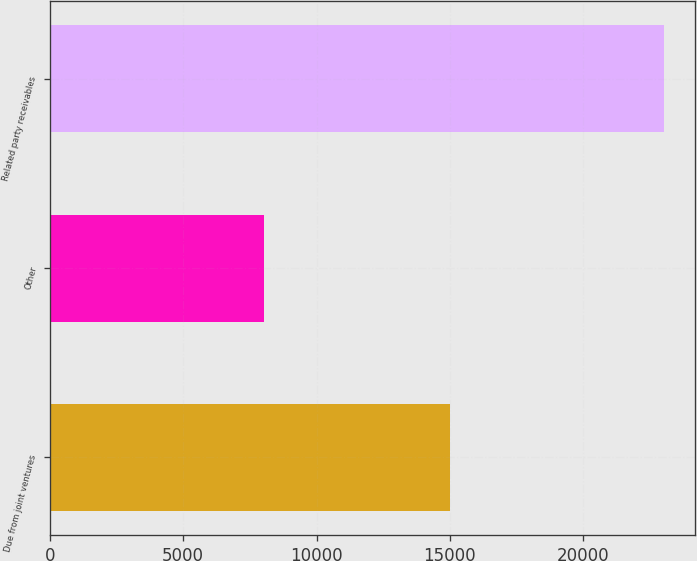<chart> <loc_0><loc_0><loc_500><loc_500><bar_chart><fcel>Due from joint ventures<fcel>Other<fcel>Related party receivables<nl><fcel>15025<fcel>8014<fcel>23039<nl></chart> 